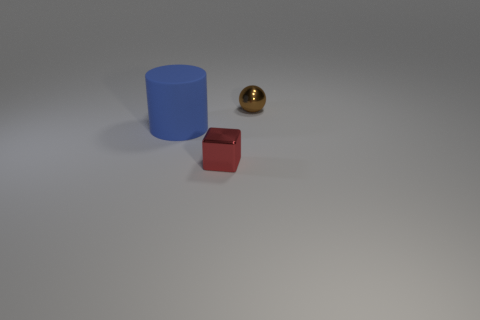There is a thing that is on the right side of the red metal thing; is its size the same as the cylinder?
Ensure brevity in your answer.  No. Is the material of the thing behind the blue cylinder the same as the tiny object that is to the left of the small brown shiny thing?
Your response must be concise. Yes. Is there a brown metallic sphere that has the same size as the red thing?
Your answer should be very brief. Yes. There is a metal object that is behind the thing that is left of the small shiny object in front of the large matte cylinder; what is its shape?
Offer a terse response. Sphere. Are there more metal things in front of the blue cylinder than large brown matte cubes?
Your answer should be compact. Yes. Are there any red shiny things of the same shape as the rubber thing?
Provide a succinct answer. No. Do the large cylinder and the tiny object on the right side of the tiny red shiny thing have the same material?
Ensure brevity in your answer.  No. The metal block is what color?
Your response must be concise. Red. There is a shiny object that is to the left of the shiny object that is behind the small red block; what number of spheres are to the left of it?
Your response must be concise. 0. There is a blue rubber cylinder; are there any small brown metal spheres on the right side of it?
Ensure brevity in your answer.  Yes. 